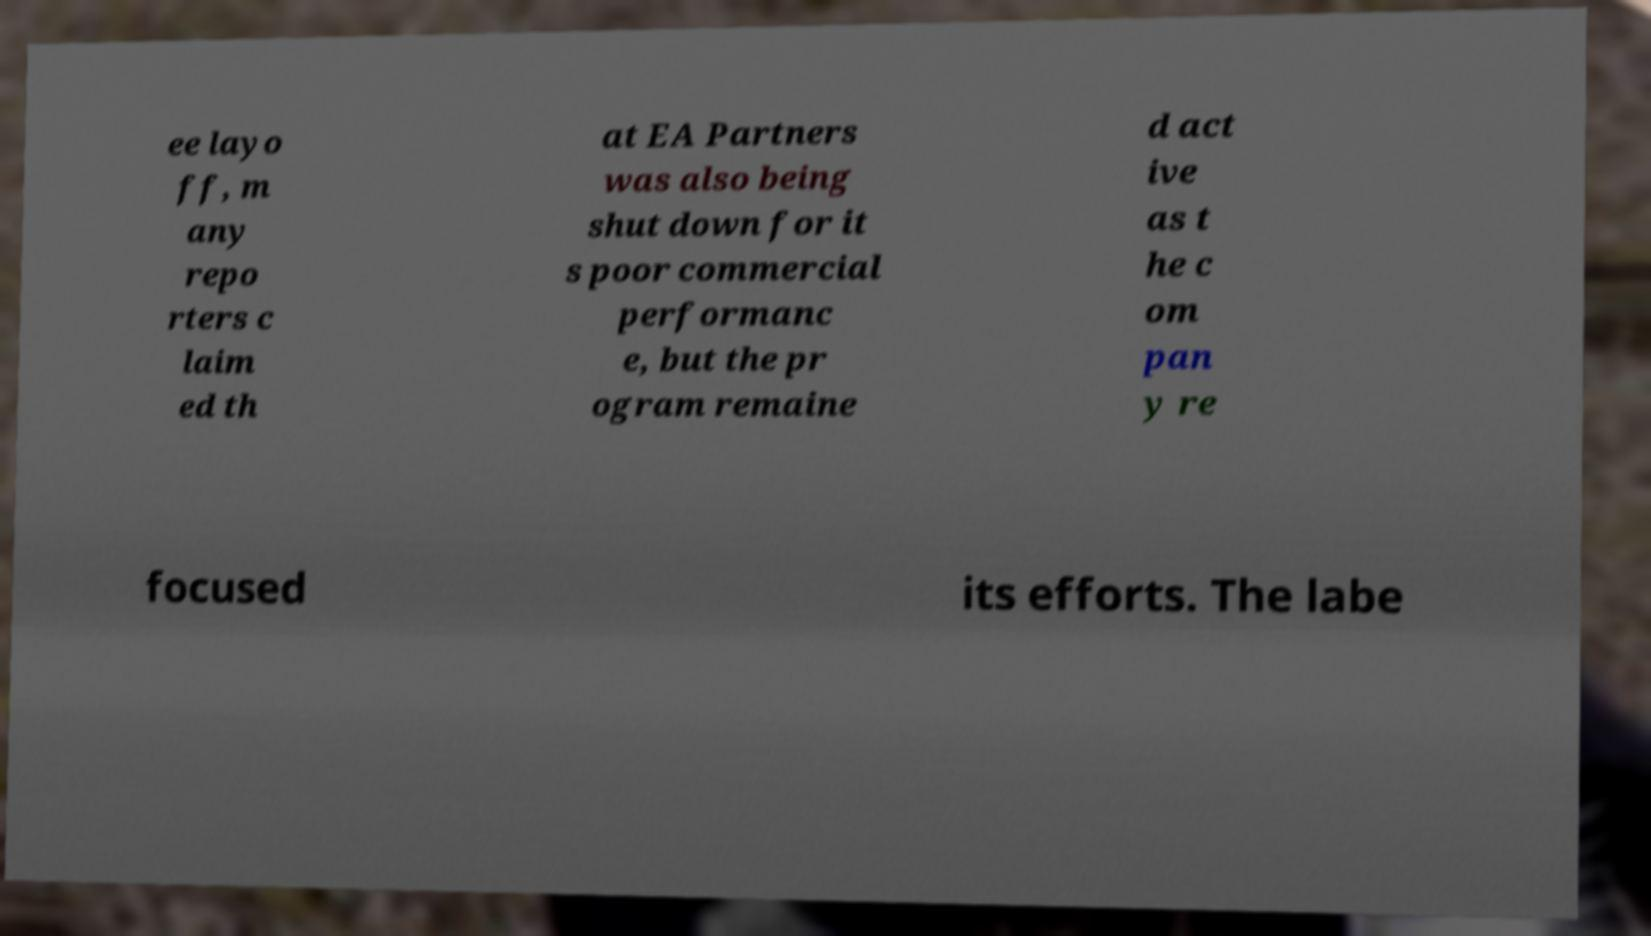Can you read and provide the text displayed in the image?This photo seems to have some interesting text. Can you extract and type it out for me? ee layo ff, m any repo rters c laim ed th at EA Partners was also being shut down for it s poor commercial performanc e, but the pr ogram remaine d act ive as t he c om pan y re focused its efforts. The labe 